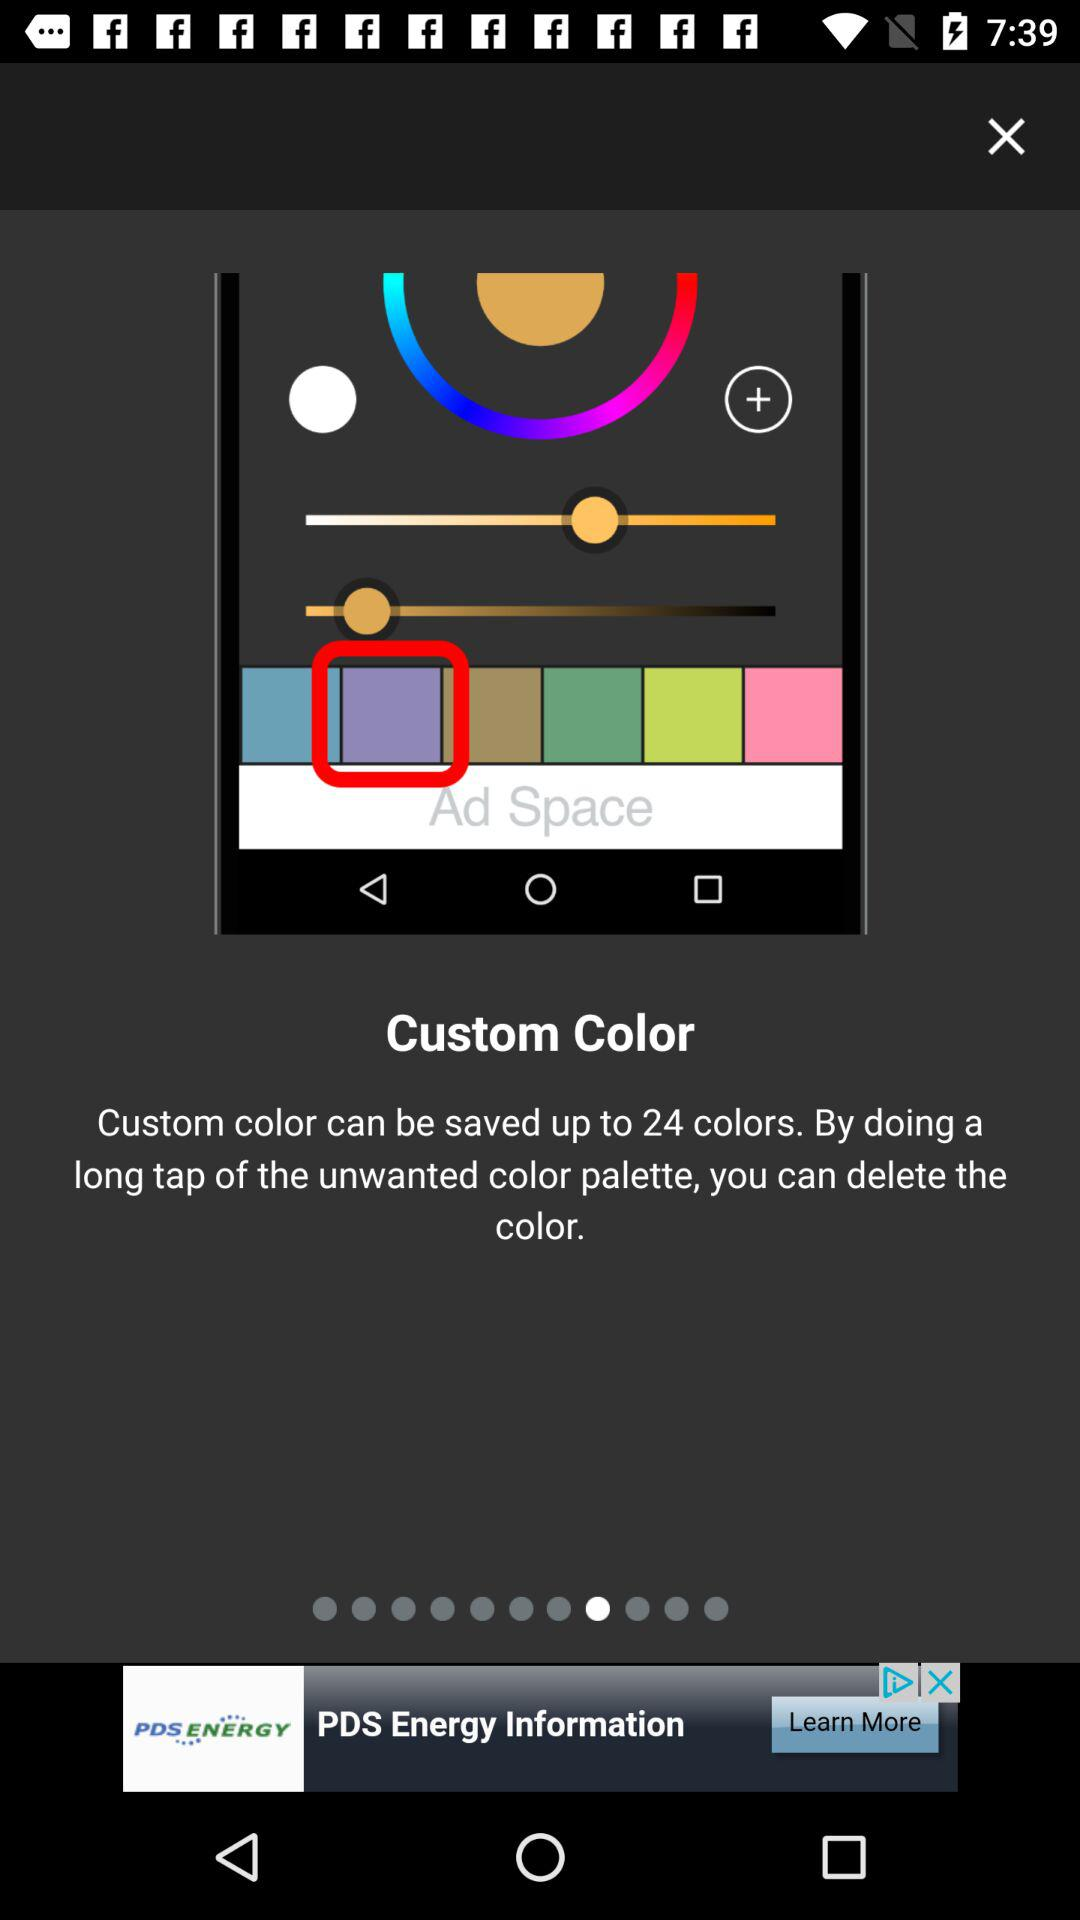How many colors can be saved in the custom color palette?
Answer the question using a single word or phrase. 24 